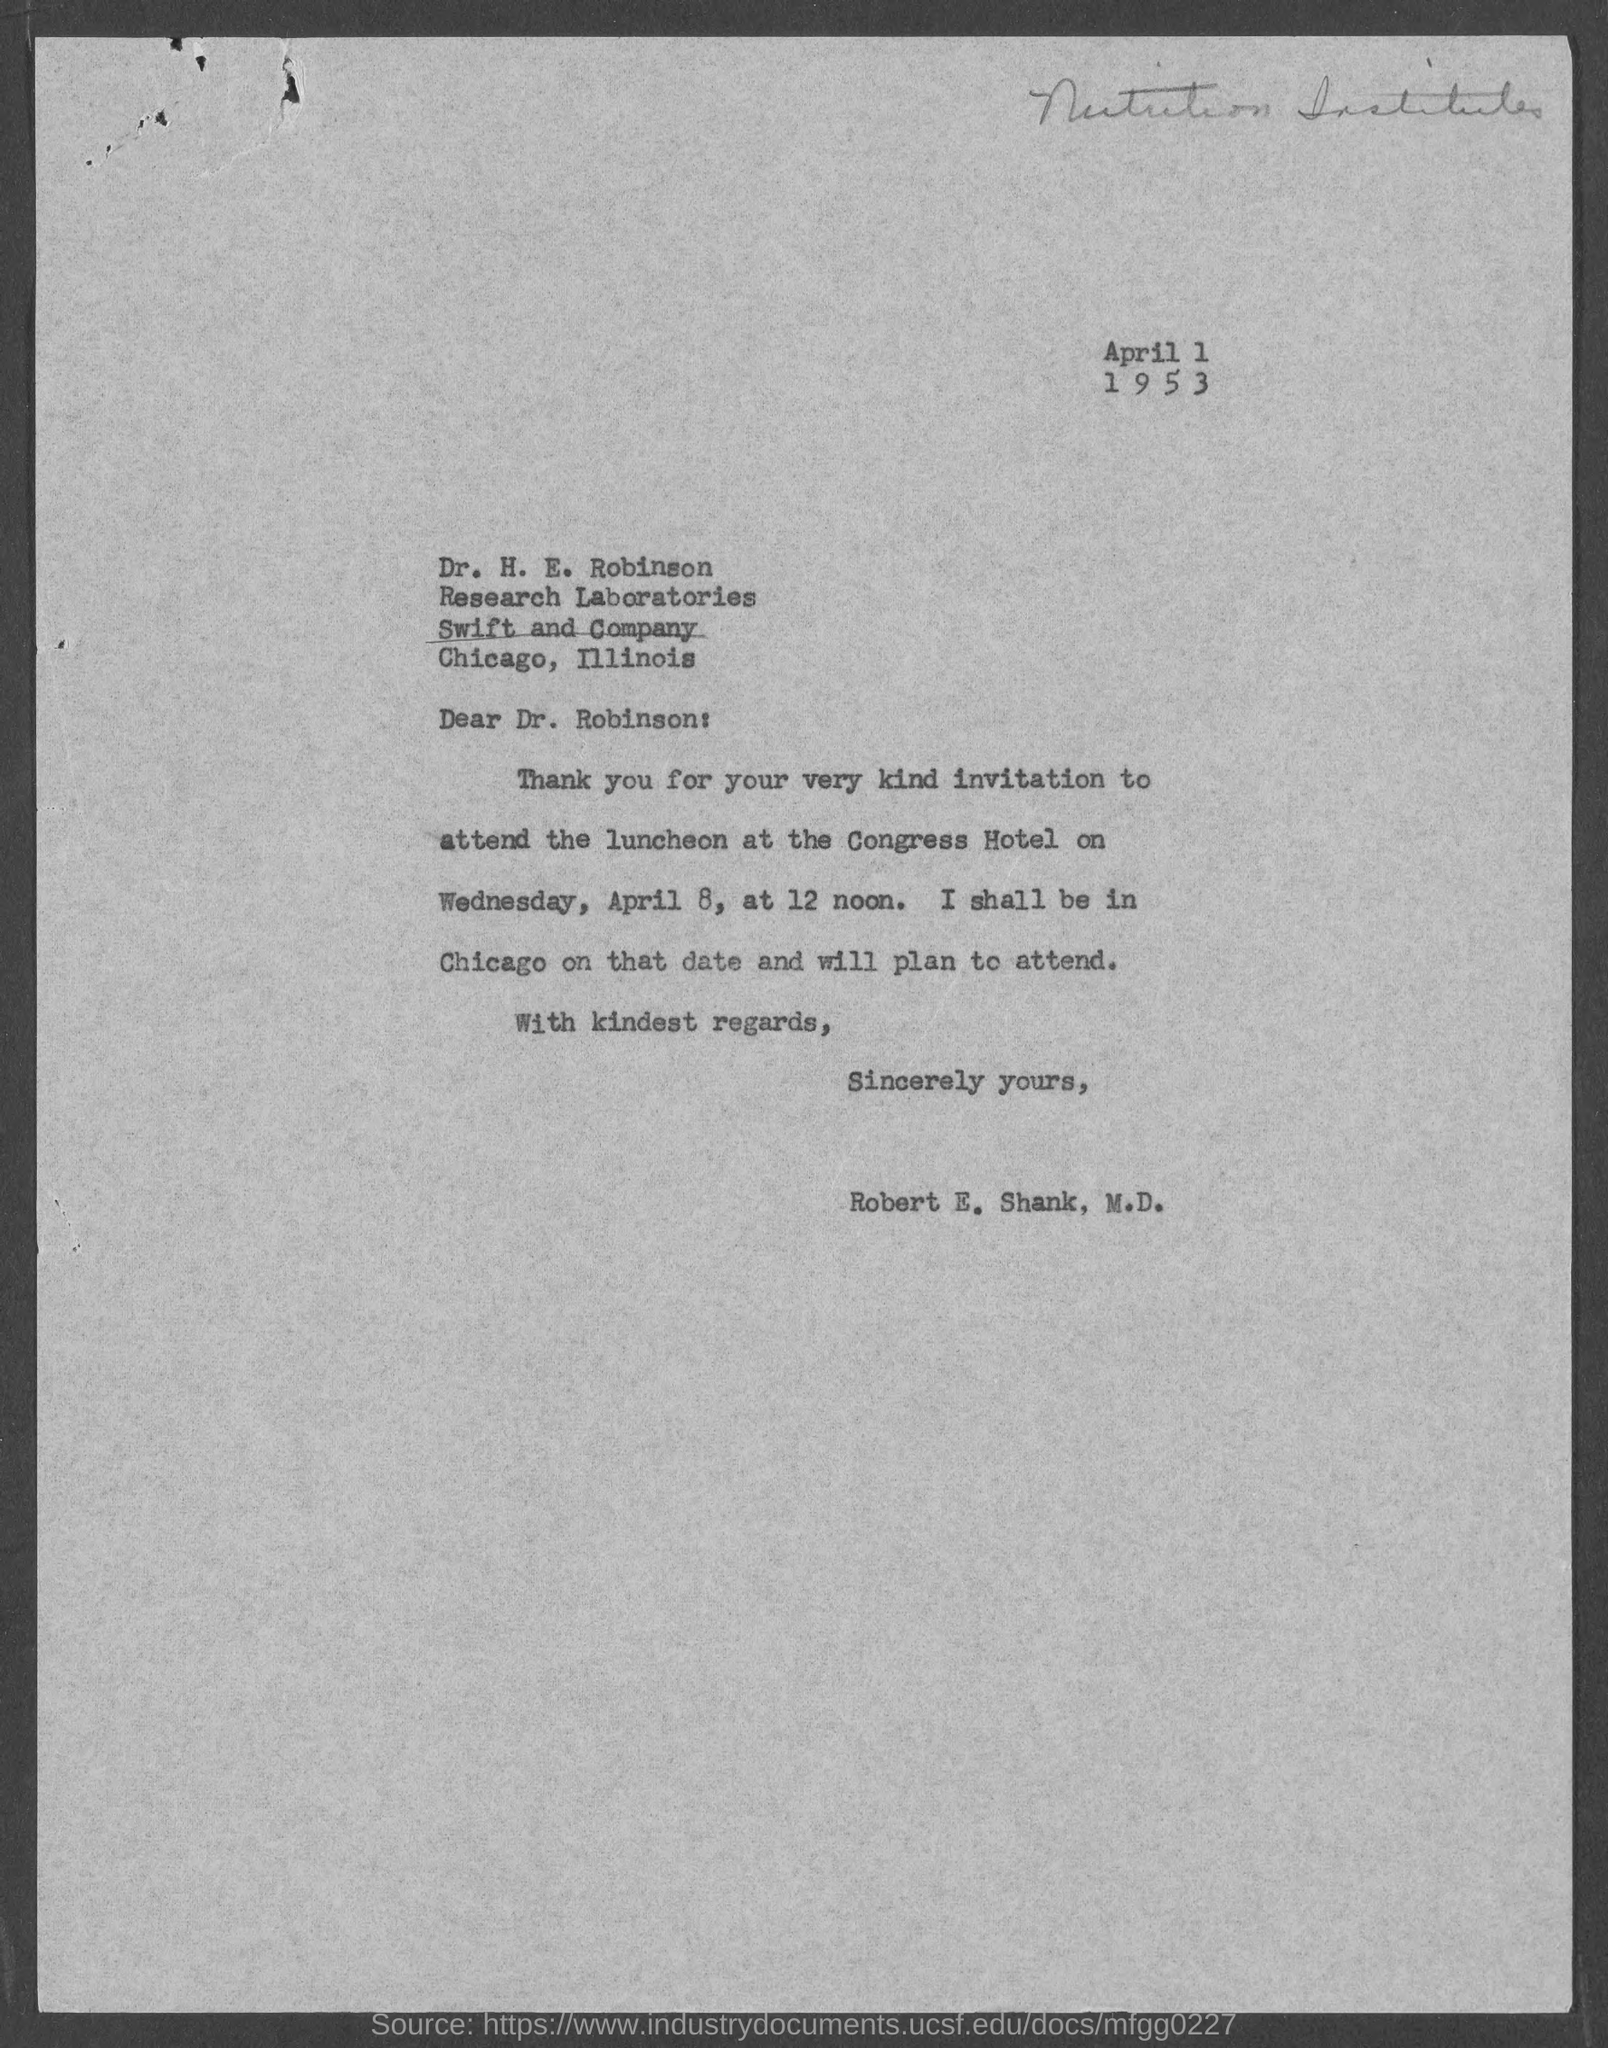Who is the Memorandum addressed to ?
Offer a very short reply. Dr. H. E. Robinson. Who is the Memorandum from ?
Provide a short and direct response. Robert E. Shank, M.D. 